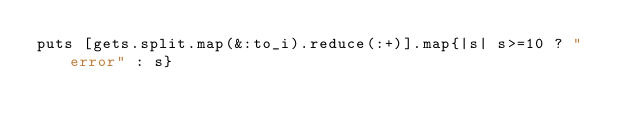<code> <loc_0><loc_0><loc_500><loc_500><_Ruby_>puts [gets.split.map(&:to_i).reduce(:+)].map{|s| s>=10 ? "error" : s}</code> 